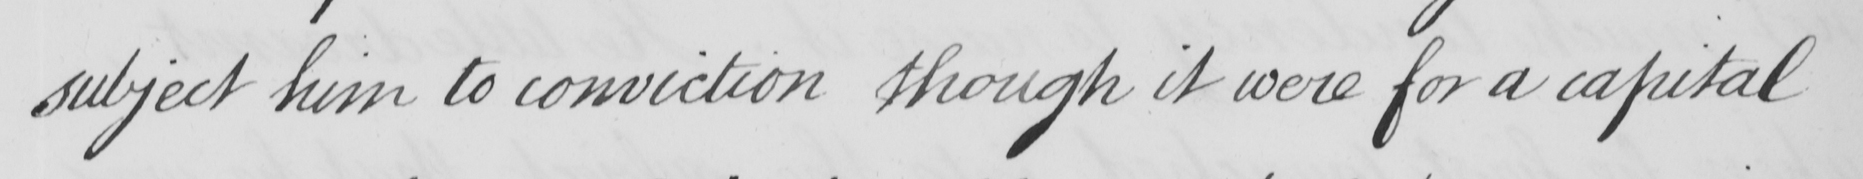Transcribe the text shown in this historical manuscript line. subject him to conviction though it were for a capital 